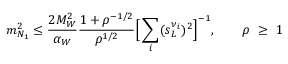Convert formula to latex. <formula><loc_0><loc_0><loc_500><loc_500>m _ { N _ { 1 } } ^ { 2 } \leq \frac { 2 M _ { W } ^ { 2 } } { \alpha _ { W } } \frac { 1 + \rho ^ { - 1 / 2 } } { \rho ^ { 1 / 2 } } \left [ \sum _ { i } ( s _ { L } ^ { \nu _ { i } } ) ^ { 2 } \right ] ^ { - 1 } , \quad \rho \ \geq \ 1</formula> 